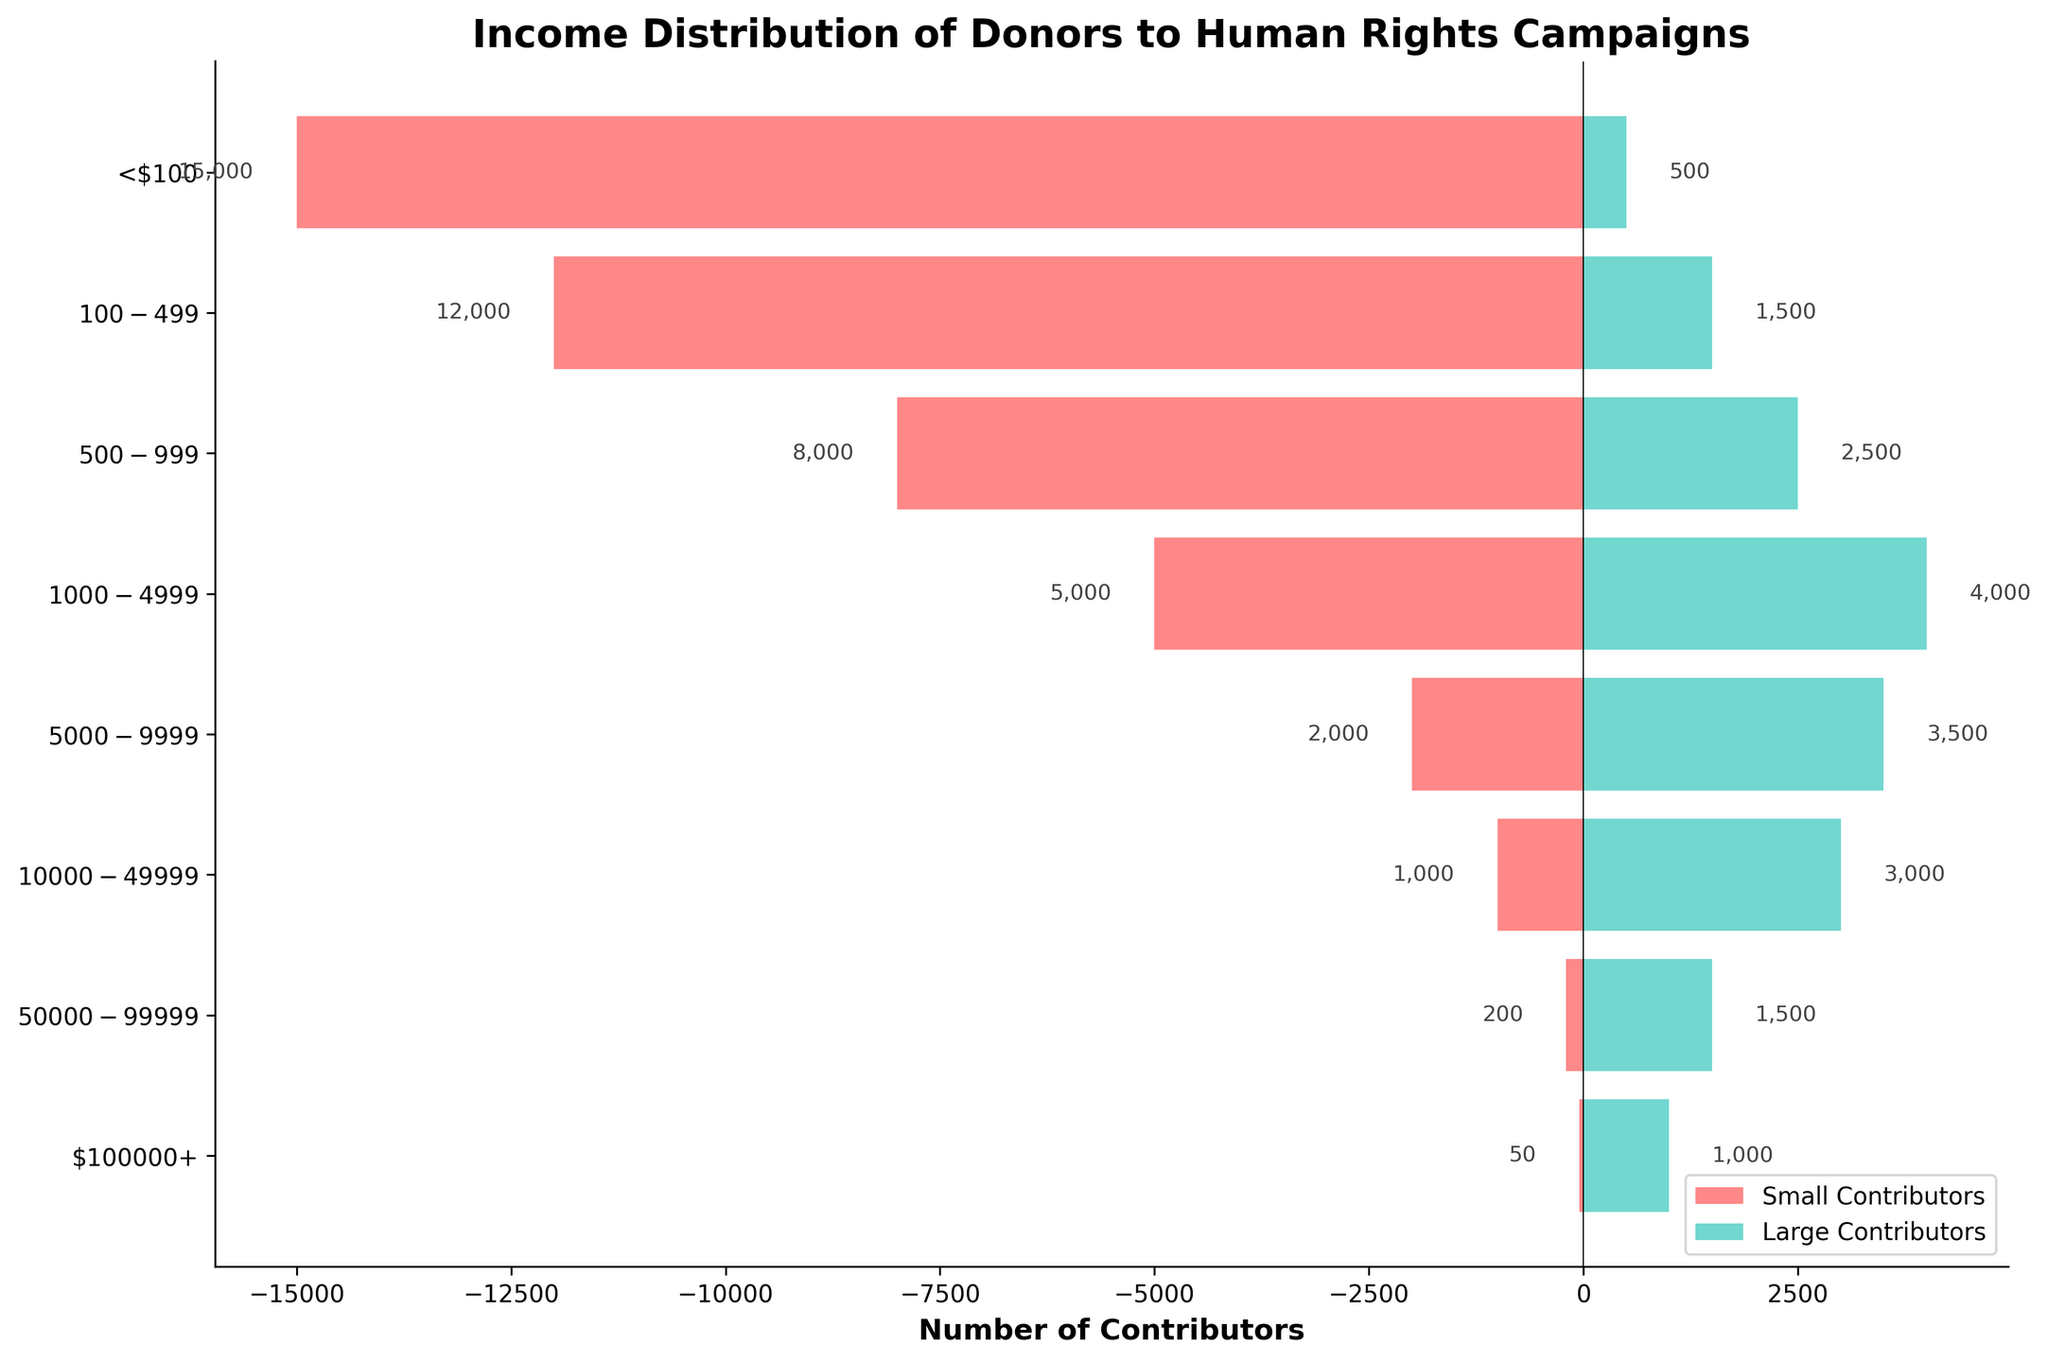What's the title of the figure? The title is located at the top of the figure and is displayed in bold. The title of our figure shows the overall topic.
Answer: Income Distribution of Donors to Human Rights Campaigns What are the two categories of contributors shown in the figure? The categories can be identified by the two colors in the bars, along with the legend. We have: Small Contributors and Large Contributors.
Answer: Small Contributors, Large Contributors Which income group has the highest number of large contributors? By comparing the lengths of the bars representing large contributors for each income group, the longest bar corresponds to the $1000-$4999 group.
Answer: $1000-$4999 How many small contributors are there in the <$100 income group? The number can be seen from the label inside the leftmost horizontal bar for the “<$100” group, highlighted in the figure.
Answer: 15,000 Compare the number of small and large contributors in the $5000-$9999 income group. Which is higher? By visually comparing the length of the bars for the $5000-$9999 income group, the large contributors' bar is longer than the small contributors' bar.
Answer: large contributors How many more small contributors are there than large contributors in the $100-$499 income group? Subtract the value of large contributors (1,500) from that of small contributors (12,000) for the $100-$499 group. The calculation is: 12,000 - 1,500.
Answer: 10,500 What’s the total number of contributors in the $500-$999 group? Sum the number of small contributors (8,000) and large contributors (2,500) in the $500-$999 income group. The calculation is: 8,000 + 2,500.
Answer: 10,500 Which income group has the smallest number of small contributors? By comparing the lengths of the bars representing small contributors for each income group, the shortest bar corresponds to the $100,000+ group.
Answer: $100,000+ Is the number of large contributors in the $10,000-$49,999 income group higher than that in the $5,000-$9,999 group? Compare the lengths of the bars for large contributors in both income groups. The $10,000-$49,999 bar is shorter than the $5,000-$9,999 bar.
Answer: No For the income group $100,000+, what is the ratio of large contributors to small contributors? Divide the number of large contributors (1,000) by the number of small contributors (50) in the $100,000+ group. The calculation is 1,000 / 50.
Answer: 20 